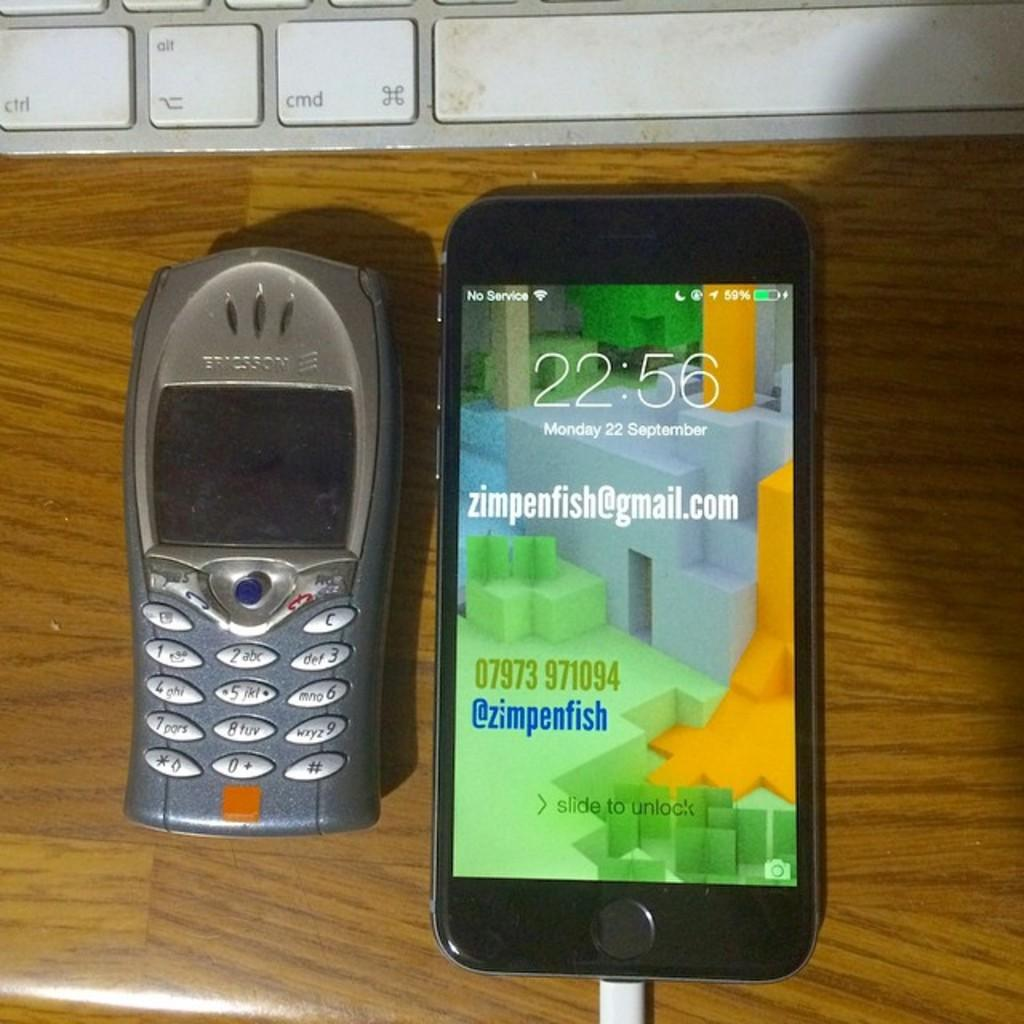<image>
Describe the image concisely. the ericson phone is turned off, but the smart phone beside it is on 